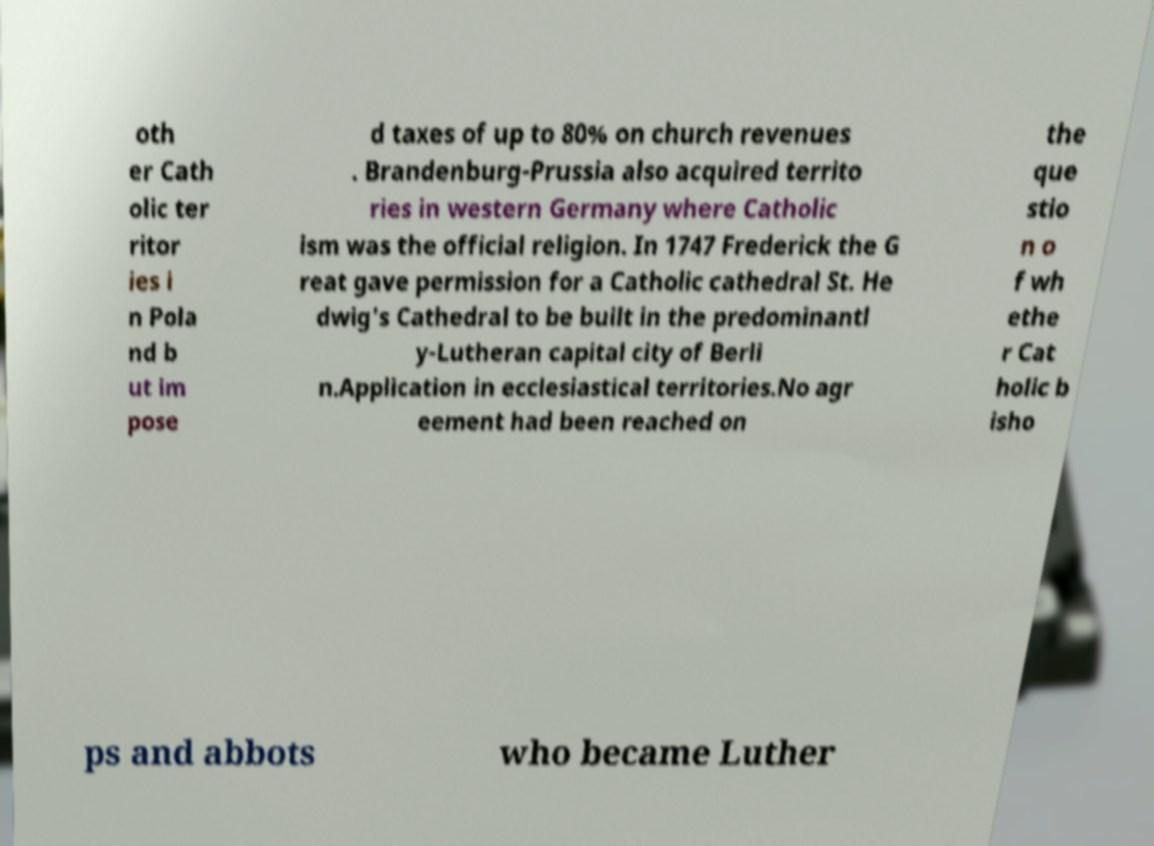Can you accurately transcribe the text from the provided image for me? oth er Cath olic ter ritor ies i n Pola nd b ut im pose d taxes of up to 80% on church revenues . Brandenburg-Prussia also acquired territo ries in western Germany where Catholic ism was the official religion. In 1747 Frederick the G reat gave permission for a Catholic cathedral St. He dwig's Cathedral to be built in the predominantl y-Lutheran capital city of Berli n.Application in ecclesiastical territories.No agr eement had been reached on the que stio n o f wh ethe r Cat holic b isho ps and abbots who became Luther 